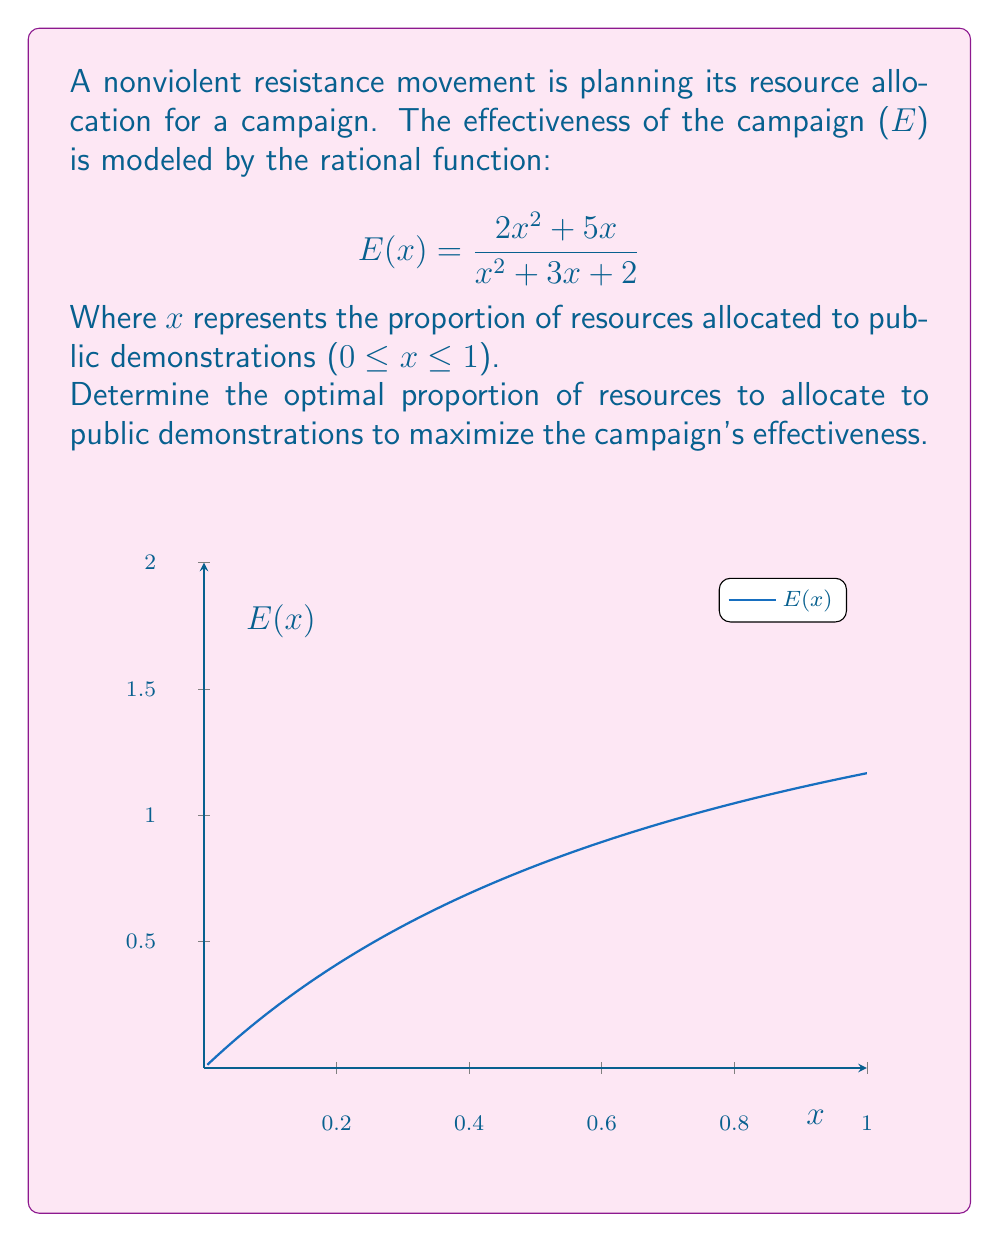Can you answer this question? To find the optimal proportion of resources, we need to find the maximum value of E(x) in the interval [0,1]. We can do this by following these steps:

1) First, let's find the derivative of E(x):

   $$E'(x) = \frac{(2x^2 + 5x)'(x^2 + 3x + 2) - (2x^2 + 5x)(x^2 + 3x + 2)'}{(x^2 + 3x + 2)^2}$$

2) Simplify:
   
   $$E'(x) = \frac{(4x + 5)(x^2 + 3x + 2) - (2x^2 + 5x)(2x + 3)}{(x^2 + 3x + 2)^2}$$

3) Expand and simplify further:

   $$E'(x) = \frac{4x^3 + 12x^2 + 8x + 5x^2 + 15x + 10 - 4x^3 - 6x^2 - 10x^2 - 15x}{(x^2 + 3x + 2)^2}$$

   $$E'(x) = \frac{x^2 + 8x + 10}{(x^2 + 3x + 2)^2}$$

4) To find the critical points, set E'(x) = 0:

   $$\frac{x^2 + 8x + 10}{(x^2 + 3x + 2)^2} = 0$$

   The numerator is always positive for real x, so there are no critical points.

5) Since there are no critical points in the interval [0,1], the maximum must occur at one of the endpoints. Let's evaluate E(x) at x = 0 and x = 1:

   $$E(0) = \frac{2(0)^2 + 5(0)}{(0)^2 + 3(0) + 2} = 0$$

   $$E(1) = \frac{2(1)^2 + 5(1)}{(1)^2 + 3(1) + 2} = \frac{7}{6} \approx 1.17$$

6) Therefore, the maximum effectiveness occurs when x = 1.
Answer: $x = 1$ (100% allocation to public demonstrations) 